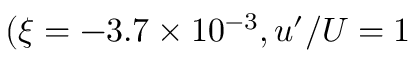<formula> <loc_0><loc_0><loc_500><loc_500>( \xi = - 3 . 7 \times 1 0 ^ { - 3 } , u ^ { \prime } / U = 1 \</formula> 